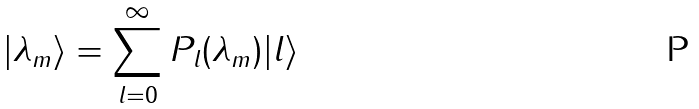<formula> <loc_0><loc_0><loc_500><loc_500>| \lambda _ { m } \rangle = \sum _ { l = 0 } ^ { \infty } P _ { l } ( \lambda _ { m } ) | l \rangle</formula> 